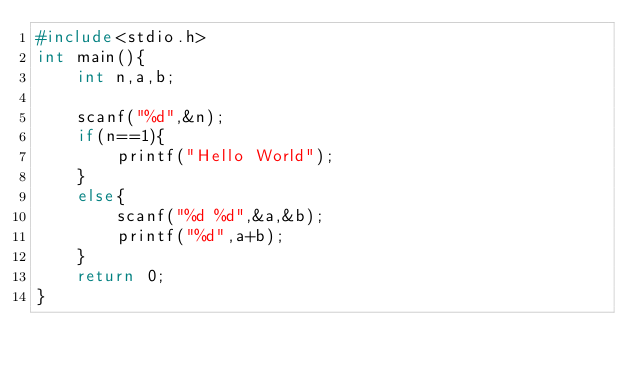<code> <loc_0><loc_0><loc_500><loc_500><_C_>#include<stdio.h>
int main(){
    int n,a,b;
    
    scanf("%d",&n);
    if(n==1){
        printf("Hello World");
    }
    else{
        scanf("%d %d",&a,&b);
        printf("%d",a+b);
    }
    return 0;   
}</code> 